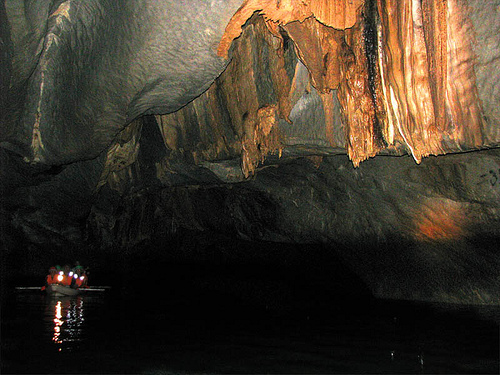<image>
Can you confirm if the darkness is behind the light? No. The darkness is not behind the light. From this viewpoint, the darkness appears to be positioned elsewhere in the scene. 